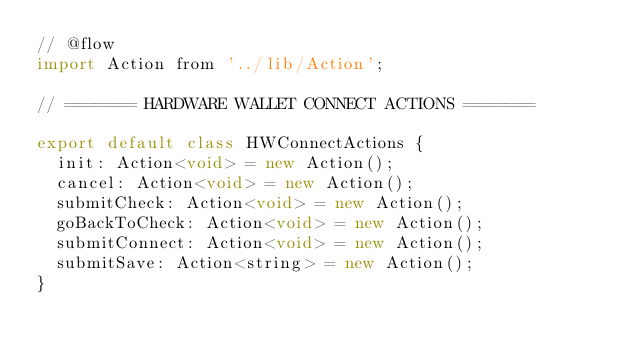Convert code to text. <code><loc_0><loc_0><loc_500><loc_500><_JavaScript_>// @flow
import Action from '../lib/Action';

// ======= HARDWARE WALLET CONNECT ACTIONS =======

export default class HWConnectActions {
  init: Action<void> = new Action();
  cancel: Action<void> = new Action();
  submitCheck: Action<void> = new Action();
  goBackToCheck: Action<void> = new Action();
  submitConnect: Action<void> = new Action();
  submitSave: Action<string> = new Action();
}
</code> 